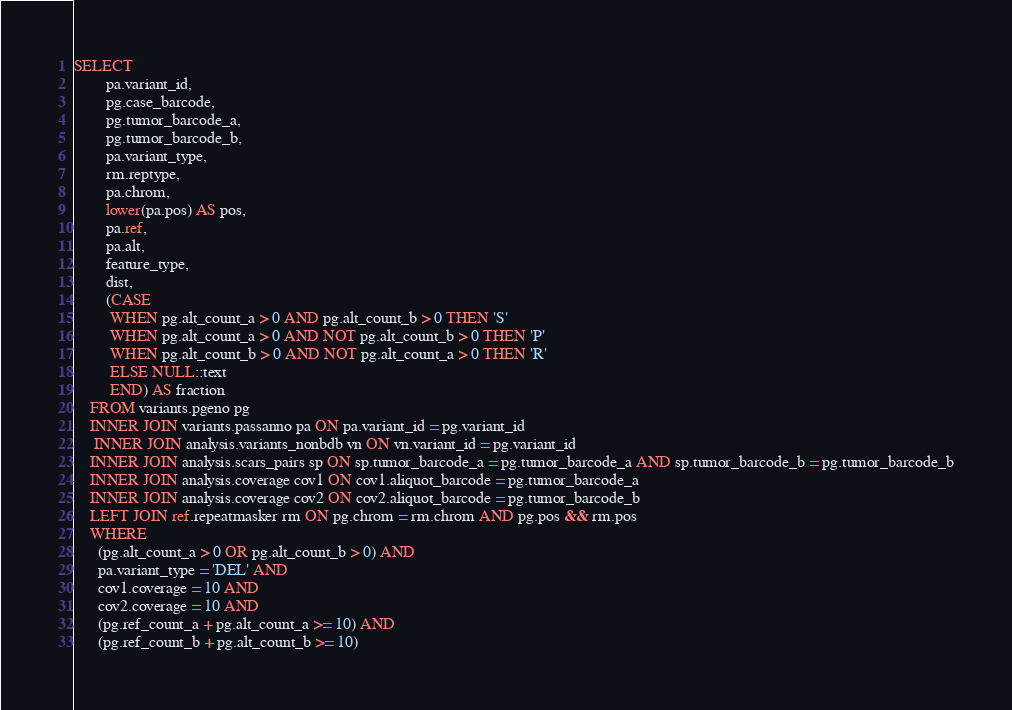<code> <loc_0><loc_0><loc_500><loc_500><_SQL_>SELECT
        pa.variant_id,
        pg.case_barcode,
        pg.tumor_barcode_a,
        pg.tumor_barcode_b,
        pa.variant_type,
		rm.reptype,
        pa.chrom,
        lower(pa.pos) AS pos,
        pa.ref,
        pa.alt,
        feature_type, 
        dist,
        (CASE
         WHEN pg.alt_count_a > 0 AND pg.alt_count_b > 0 THEN 'S'
         WHEN pg.alt_count_a > 0 AND NOT pg.alt_count_b > 0 THEN 'P'
         WHEN pg.alt_count_b > 0 AND NOT pg.alt_count_a > 0 THEN 'R'
         ELSE NULL::text
         END) AS fraction
    FROM variants.pgeno pg
    INNER JOIN variants.passanno pa ON pa.variant_id = pg.variant_id
     INNER JOIN analysis.variants_nonbdb vn ON vn.variant_id = pg.variant_id
    INNER JOIN analysis.scars_pairs sp ON sp.tumor_barcode_a = pg.tumor_barcode_a AND sp.tumor_barcode_b = pg.tumor_barcode_b
    INNER JOIN analysis.coverage cov1 ON cov1.aliquot_barcode = pg.tumor_barcode_a
    INNER JOIN analysis.coverage cov2 ON cov2.aliquot_barcode = pg.tumor_barcode_b
	LEFT JOIN ref.repeatmasker rm ON pg.chrom = rm.chrom AND pg.pos && rm.pos
    WHERE
      (pg.alt_count_a > 0 OR pg.alt_count_b > 0) AND
      pa.variant_type = 'DEL' AND
      cov1.coverage = 10 AND
      cov2.coverage = 10 AND
      (pg.ref_count_a + pg.alt_count_a >= 10) AND
      (pg.ref_count_b + pg.alt_count_b >= 10)</code> 